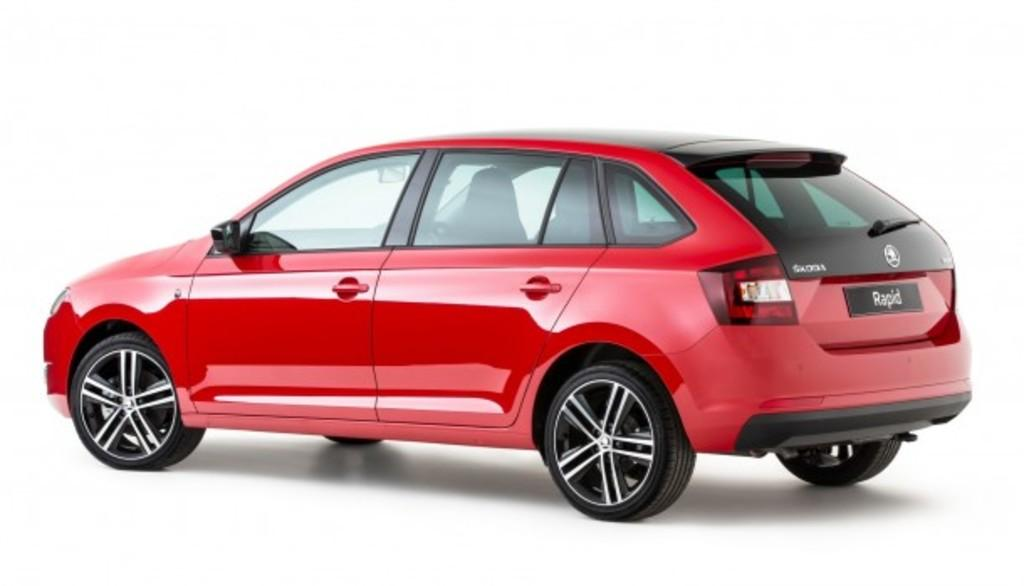What is the main subject of the picture? The main subject of the picture is a car. Can you describe the color of the car? The car is red in color. What can be seen in the background of the image? The background of the image is white. What type of argument can be seen taking place in the image? There is no argument present in the image; it features a red car against a white background. What kind of experience can be gained from observing the car in the image? The image does not depict an experience, but rather a static scene of a red car against a white background. 